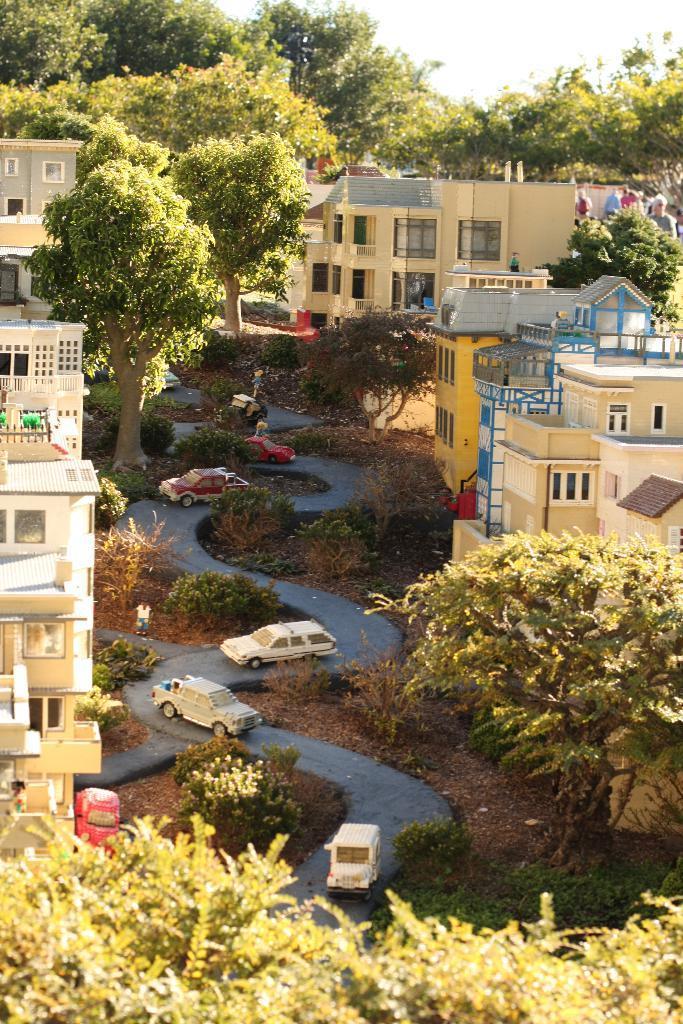Can you describe this image briefly? In this image there are buildings, trees, plants, vehicles, people and sky. Vehicles are on the road. 